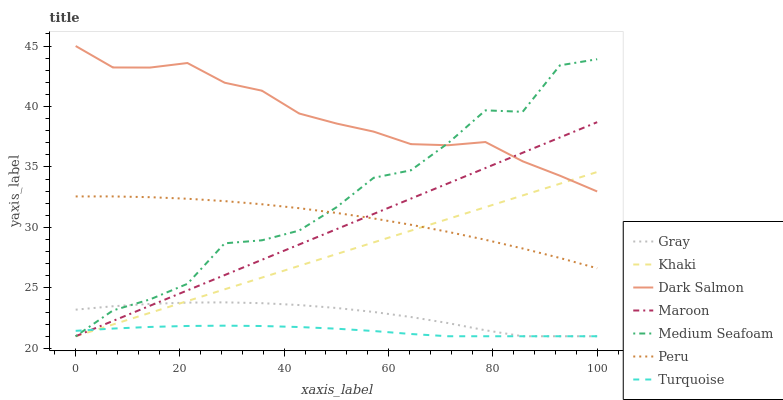Does Turquoise have the minimum area under the curve?
Answer yes or no. Yes. Does Dark Salmon have the maximum area under the curve?
Answer yes or no. Yes. Does Khaki have the minimum area under the curve?
Answer yes or no. No. Does Khaki have the maximum area under the curve?
Answer yes or no. No. Is Khaki the smoothest?
Answer yes or no. Yes. Is Medium Seafoam the roughest?
Answer yes or no. Yes. Is Turquoise the smoothest?
Answer yes or no. No. Is Turquoise the roughest?
Answer yes or no. No. Does Gray have the lowest value?
Answer yes or no. Yes. Does Dark Salmon have the lowest value?
Answer yes or no. No. Does Dark Salmon have the highest value?
Answer yes or no. Yes. Does Khaki have the highest value?
Answer yes or no. No. Is Gray less than Dark Salmon?
Answer yes or no. Yes. Is Peru greater than Turquoise?
Answer yes or no. Yes. Does Medium Seafoam intersect Peru?
Answer yes or no. Yes. Is Medium Seafoam less than Peru?
Answer yes or no. No. Is Medium Seafoam greater than Peru?
Answer yes or no. No. Does Gray intersect Dark Salmon?
Answer yes or no. No. 